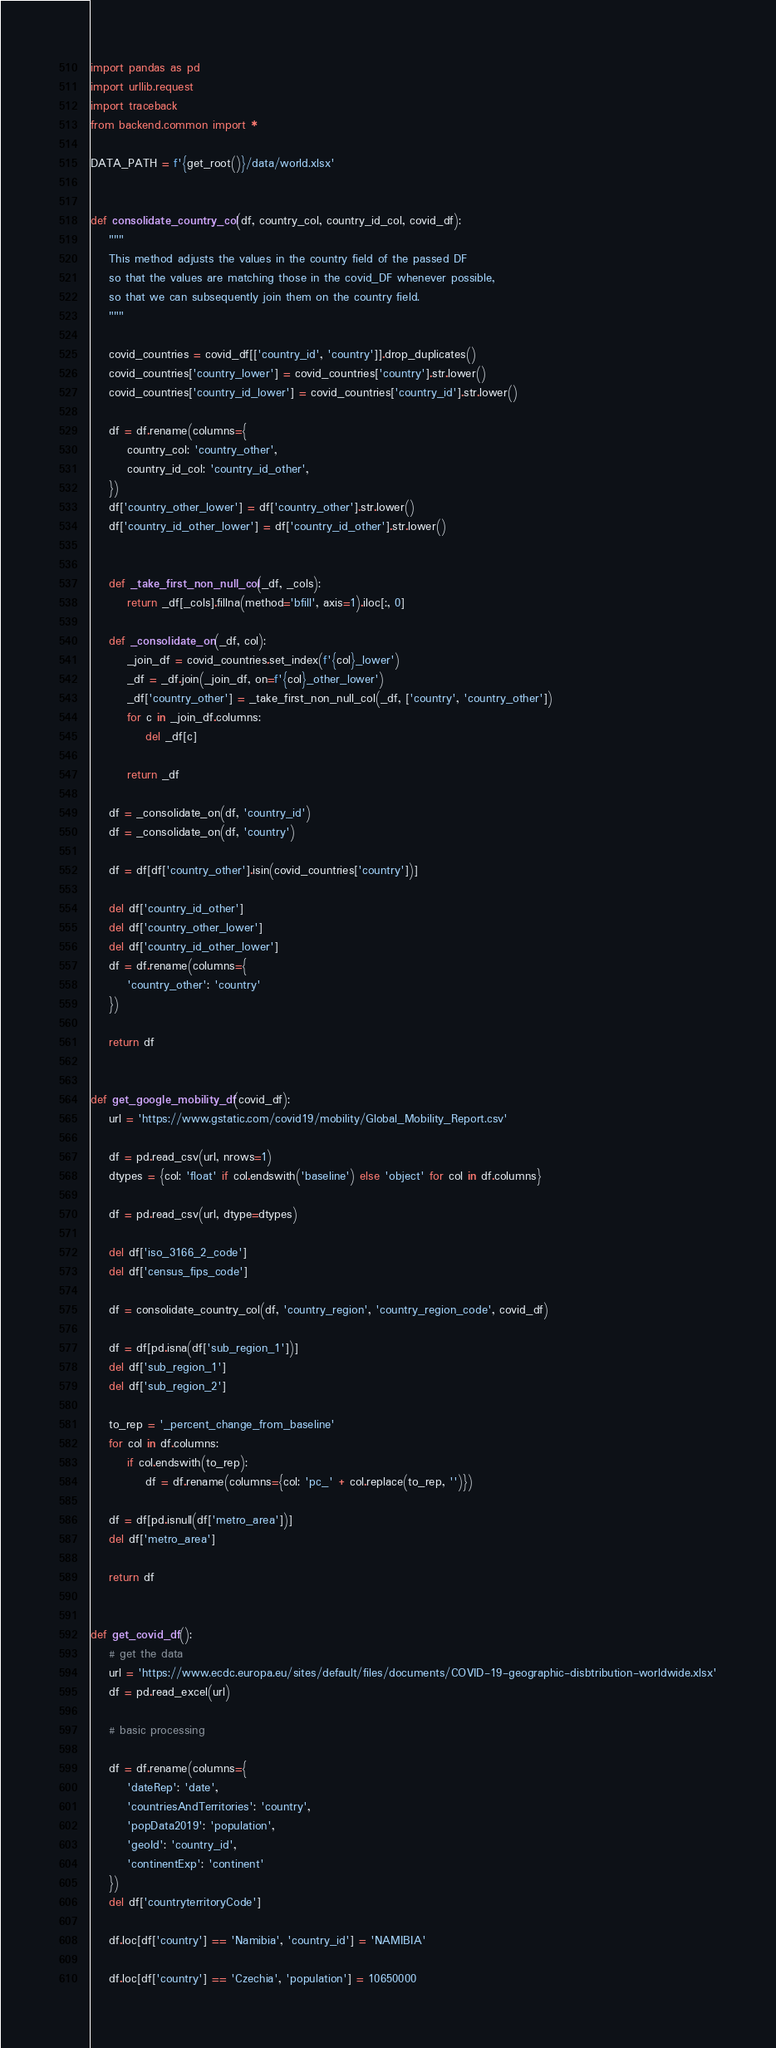<code> <loc_0><loc_0><loc_500><loc_500><_Python_>import pandas as pd
import urllib.request
import traceback
from backend.common import *

DATA_PATH = f'{get_root()}/data/world.xlsx'


def consolidate_country_col(df, country_col, country_id_col, covid_df):
    """
    This method adjusts the values in the country field of the passed DF
    so that the values are matching those in the covid_DF whenever possible,
    so that we can subsequently join them on the country field.    
    """ 
    
    covid_countries = covid_df[['country_id', 'country']].drop_duplicates()
    covid_countries['country_lower'] = covid_countries['country'].str.lower()
    covid_countries['country_id_lower'] = covid_countries['country_id'].str.lower()
    
    df = df.rename(columns={
        country_col: 'country_other',
        country_id_col: 'country_id_other',
    })
    df['country_other_lower'] = df['country_other'].str.lower()
    df['country_id_other_lower'] = df['country_id_other'].str.lower()
    
    
    def _take_first_non_null_col(_df, _cols):
        return _df[_cols].fillna(method='bfill', axis=1).iloc[:, 0]
    
    def _consolidate_on(_df, col):
        _join_df = covid_countries.set_index(f'{col}_lower')
        _df = _df.join(_join_df, on=f'{col}_other_lower')
        _df['country_other'] = _take_first_non_null_col(_df, ['country', 'country_other'])
        for c in _join_df.columns:
            del _df[c]
            
        return _df
            
    df = _consolidate_on(df, 'country_id')
    df = _consolidate_on(df, 'country')
    
    df = df[df['country_other'].isin(covid_countries['country'])]
    
    del df['country_id_other']
    del df['country_other_lower']
    del df['country_id_other_lower']
    df = df.rename(columns={
        'country_other': 'country'
    })
    
    return df    


def get_google_mobility_df(covid_df):
    url = 'https://www.gstatic.com/covid19/mobility/Global_Mobility_Report.csv'
    
    df = pd.read_csv(url, nrows=1)
    dtypes = {col: 'float' if col.endswith('baseline') else 'object' for col in df.columns}

    df = pd.read_csv(url, dtype=dtypes)

    del df['iso_3166_2_code']
    del df['census_fips_code']

    df = consolidate_country_col(df, 'country_region', 'country_region_code', covid_df)

    df = df[pd.isna(df['sub_region_1'])]
    del df['sub_region_1']
    del df['sub_region_2']

    to_rep = '_percent_change_from_baseline'
    for col in df.columns:
        if col.endswith(to_rep):
            df = df.rename(columns={col: 'pc_' + col.replace(to_rep, '')})

    df = df[pd.isnull(df['metro_area'])]
    del df['metro_area']

    return df


def get_covid_df():
    # get the data
    url = 'https://www.ecdc.europa.eu/sites/default/files/documents/COVID-19-geographic-disbtribution-worldwide.xlsx'
    df = pd.read_excel(url)

    # basic processing

    df = df.rename(columns={
        'dateRep': 'date',
        'countriesAndTerritories': 'country',
        'popData2019': 'population',
        'geoId': 'country_id',
        'continentExp': 'continent'
    })
    del df['countryterritoryCode']

    df.loc[df['country'] == 'Namibia', 'country_id'] = 'NAMIBIA'

    df.loc[df['country'] == 'Czechia', 'population'] = 10650000</code> 